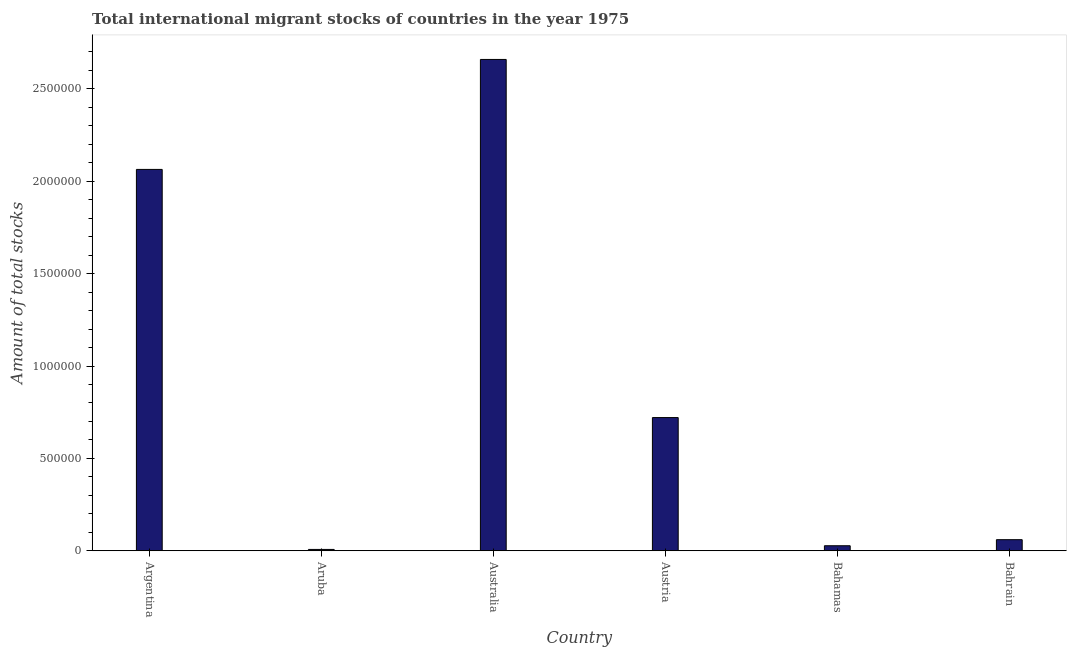Does the graph contain any zero values?
Offer a terse response. No. Does the graph contain grids?
Ensure brevity in your answer.  No. What is the title of the graph?
Your response must be concise. Total international migrant stocks of countries in the year 1975. What is the label or title of the Y-axis?
Your answer should be compact. Amount of total stocks. What is the total number of international migrant stock in Bahamas?
Give a very brief answer. 2.72e+04. Across all countries, what is the maximum total number of international migrant stock?
Your answer should be compact. 2.66e+06. Across all countries, what is the minimum total number of international migrant stock?
Give a very brief answer. 7262. In which country was the total number of international migrant stock maximum?
Your answer should be very brief. Australia. In which country was the total number of international migrant stock minimum?
Make the answer very short. Aruba. What is the sum of the total number of international migrant stock?
Provide a short and direct response. 5.54e+06. What is the difference between the total number of international migrant stock in Austria and Bahamas?
Keep it short and to the point. 6.94e+05. What is the average total number of international migrant stock per country?
Your answer should be compact. 9.23e+05. What is the median total number of international migrant stock?
Provide a succinct answer. 3.91e+05. What is the ratio of the total number of international migrant stock in Aruba to that in Bahamas?
Your response must be concise. 0.27. Is the total number of international migrant stock in Australia less than that in Bahrain?
Your response must be concise. No. Is the difference between the total number of international migrant stock in Austria and Bahamas greater than the difference between any two countries?
Provide a succinct answer. No. What is the difference between the highest and the second highest total number of international migrant stock?
Offer a very short reply. 5.95e+05. Is the sum of the total number of international migrant stock in Australia and Bahrain greater than the maximum total number of international migrant stock across all countries?
Provide a short and direct response. Yes. What is the difference between the highest and the lowest total number of international migrant stock?
Make the answer very short. 2.65e+06. In how many countries, is the total number of international migrant stock greater than the average total number of international migrant stock taken over all countries?
Your answer should be very brief. 2. Are all the bars in the graph horizontal?
Your response must be concise. No. What is the Amount of total stocks in Argentina?
Keep it short and to the point. 2.06e+06. What is the Amount of total stocks of Aruba?
Ensure brevity in your answer.  7262. What is the Amount of total stocks in Australia?
Your response must be concise. 2.66e+06. What is the Amount of total stocks of Austria?
Give a very brief answer. 7.21e+05. What is the Amount of total stocks of Bahamas?
Your answer should be compact. 2.72e+04. What is the Amount of total stocks of Bahrain?
Make the answer very short. 6.01e+04. What is the difference between the Amount of total stocks in Argentina and Aruba?
Offer a very short reply. 2.06e+06. What is the difference between the Amount of total stocks in Argentina and Australia?
Your answer should be compact. -5.95e+05. What is the difference between the Amount of total stocks in Argentina and Austria?
Keep it short and to the point. 1.34e+06. What is the difference between the Amount of total stocks in Argentina and Bahamas?
Keep it short and to the point. 2.04e+06. What is the difference between the Amount of total stocks in Argentina and Bahrain?
Offer a terse response. 2.00e+06. What is the difference between the Amount of total stocks in Aruba and Australia?
Offer a very short reply. -2.65e+06. What is the difference between the Amount of total stocks in Aruba and Austria?
Ensure brevity in your answer.  -7.14e+05. What is the difference between the Amount of total stocks in Aruba and Bahamas?
Give a very brief answer. -2.00e+04. What is the difference between the Amount of total stocks in Aruba and Bahrain?
Your answer should be very brief. -5.28e+04. What is the difference between the Amount of total stocks in Australia and Austria?
Provide a short and direct response. 1.94e+06. What is the difference between the Amount of total stocks in Australia and Bahamas?
Keep it short and to the point. 2.63e+06. What is the difference between the Amount of total stocks in Australia and Bahrain?
Give a very brief answer. 2.60e+06. What is the difference between the Amount of total stocks in Austria and Bahamas?
Provide a short and direct response. 6.94e+05. What is the difference between the Amount of total stocks in Austria and Bahrain?
Your answer should be very brief. 6.61e+05. What is the difference between the Amount of total stocks in Bahamas and Bahrain?
Your answer should be compact. -3.29e+04. What is the ratio of the Amount of total stocks in Argentina to that in Aruba?
Ensure brevity in your answer.  284.25. What is the ratio of the Amount of total stocks in Argentina to that in Australia?
Your answer should be compact. 0.78. What is the ratio of the Amount of total stocks in Argentina to that in Austria?
Your answer should be very brief. 2.86. What is the ratio of the Amount of total stocks in Argentina to that in Bahamas?
Offer a terse response. 75.84. What is the ratio of the Amount of total stocks in Argentina to that in Bahrain?
Your response must be concise. 34.35. What is the ratio of the Amount of total stocks in Aruba to that in Australia?
Give a very brief answer. 0. What is the ratio of the Amount of total stocks in Aruba to that in Austria?
Your answer should be very brief. 0.01. What is the ratio of the Amount of total stocks in Aruba to that in Bahamas?
Keep it short and to the point. 0.27. What is the ratio of the Amount of total stocks in Aruba to that in Bahrain?
Provide a short and direct response. 0.12. What is the ratio of the Amount of total stocks in Australia to that in Austria?
Provide a succinct answer. 3.69. What is the ratio of the Amount of total stocks in Australia to that in Bahamas?
Your response must be concise. 97.71. What is the ratio of the Amount of total stocks in Australia to that in Bahrain?
Give a very brief answer. 44.26. What is the ratio of the Amount of total stocks in Austria to that in Bahamas?
Your answer should be very brief. 26.49. What is the ratio of the Amount of total stocks in Austria to that in Bahrain?
Your answer should be very brief. 12. What is the ratio of the Amount of total stocks in Bahamas to that in Bahrain?
Your answer should be very brief. 0.45. 